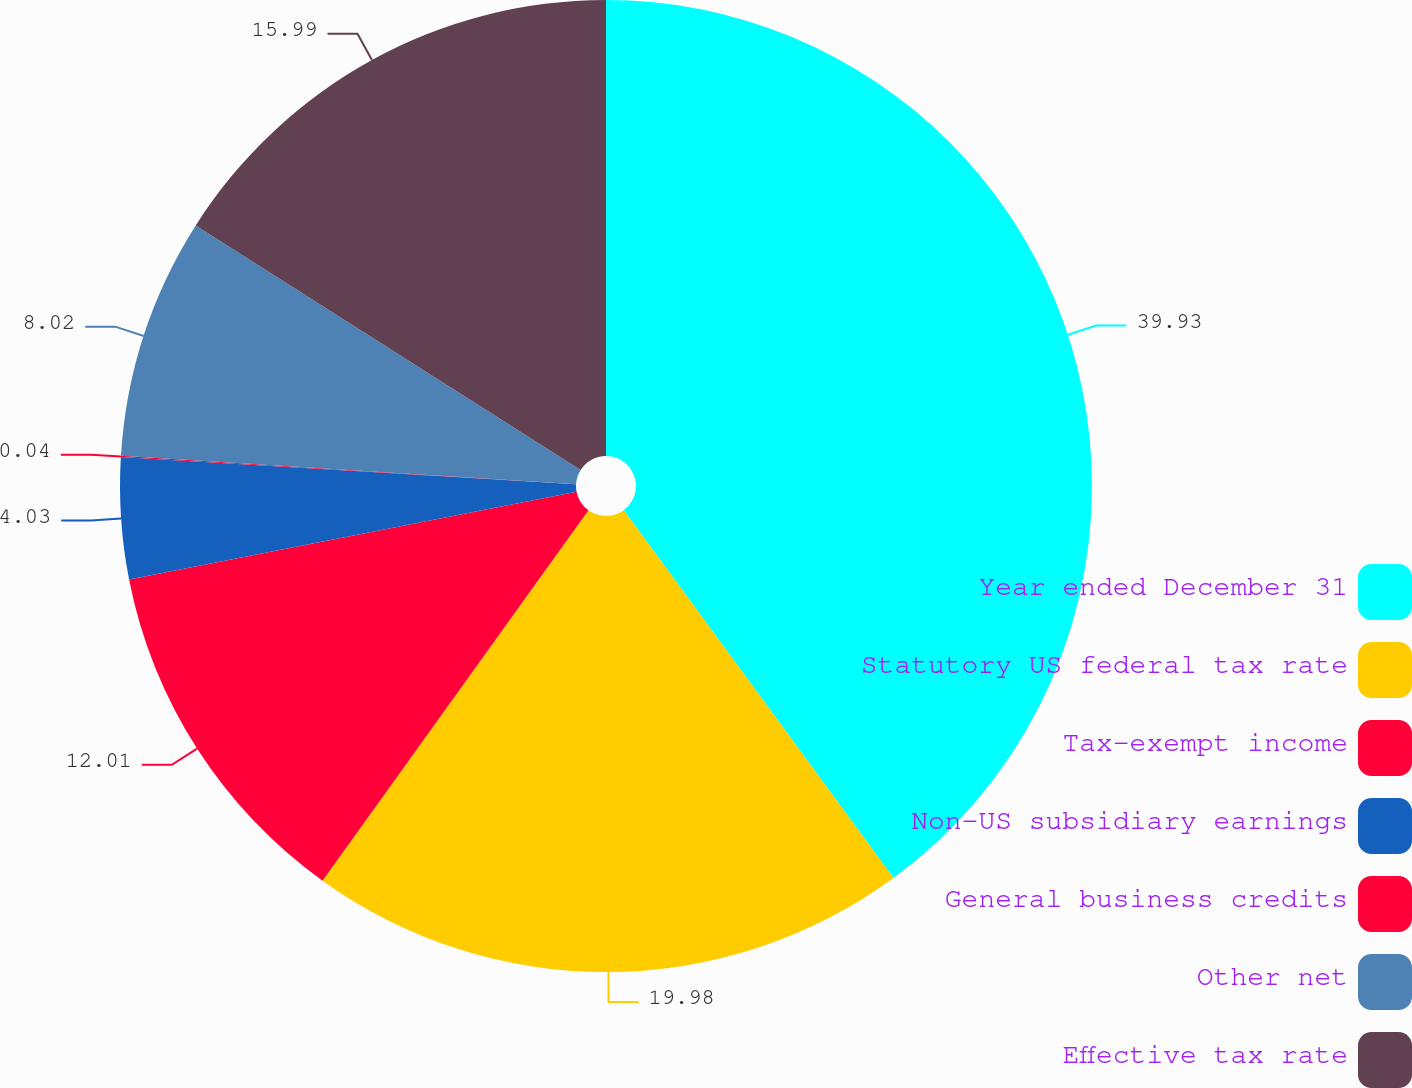Convert chart to OTSL. <chart><loc_0><loc_0><loc_500><loc_500><pie_chart><fcel>Year ended December 31<fcel>Statutory US federal tax rate<fcel>Tax-exempt income<fcel>Non-US subsidiary earnings<fcel>General business credits<fcel>Other net<fcel>Effective tax rate<nl><fcel>39.94%<fcel>19.99%<fcel>12.01%<fcel>4.03%<fcel>0.04%<fcel>8.02%<fcel>16.0%<nl></chart> 